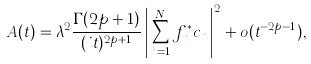<formula> <loc_0><loc_0><loc_500><loc_500>A ( t ) = \lambda ^ { 2 } \frac { \Gamma ( 2 p + 1 ) } { ( i t ) ^ { 2 p + 1 } } \left | \sum _ { n = 1 } ^ { N } f _ { n } ^ { * } c _ { n } \right | ^ { 2 } + o ( t ^ { - 2 p - 1 } ) ,</formula> 